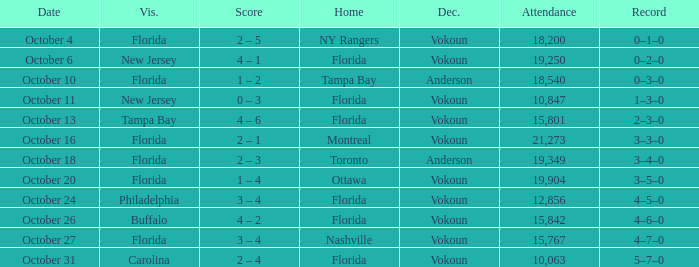What was the score on October 13? 4 – 6. 